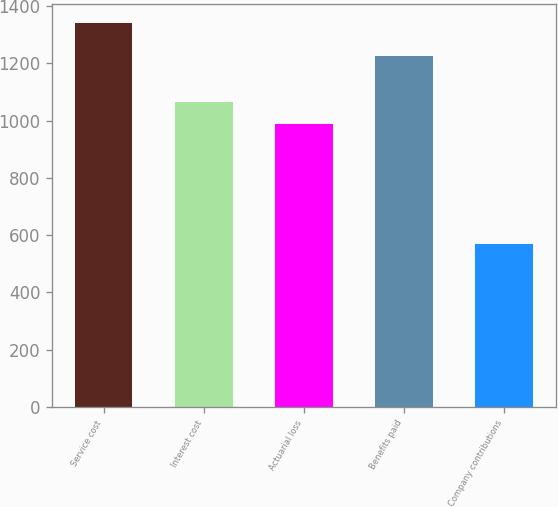Convert chart to OTSL. <chart><loc_0><loc_0><loc_500><loc_500><bar_chart><fcel>Service cost<fcel>Interest cost<fcel>Actuarial loss<fcel>Benefits paid<fcel>Company contributions<nl><fcel>1341<fcel>1064.1<fcel>987<fcel>1226<fcel>570<nl></chart> 